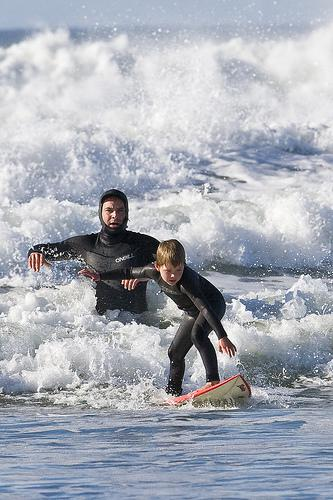Question: what is the man wearing?
Choices:
A. Swimming trunks.
B. A wetsuit.
C. Blue jeans.
D. Hazmat.suit.
Answer with the letter. Answer: B Question: where was this taken?
Choices:
A. At the beach.
B. At a farm.
C. At a rodeo.
D. At a pond.
Answer with the letter. Answer: A Question: who manufactured the man's wetsuit?
Choices:
A. Nike.
B. Wetsareus.
C. Polo.
D. O'Neill.
Answer with the letter. Answer: D 